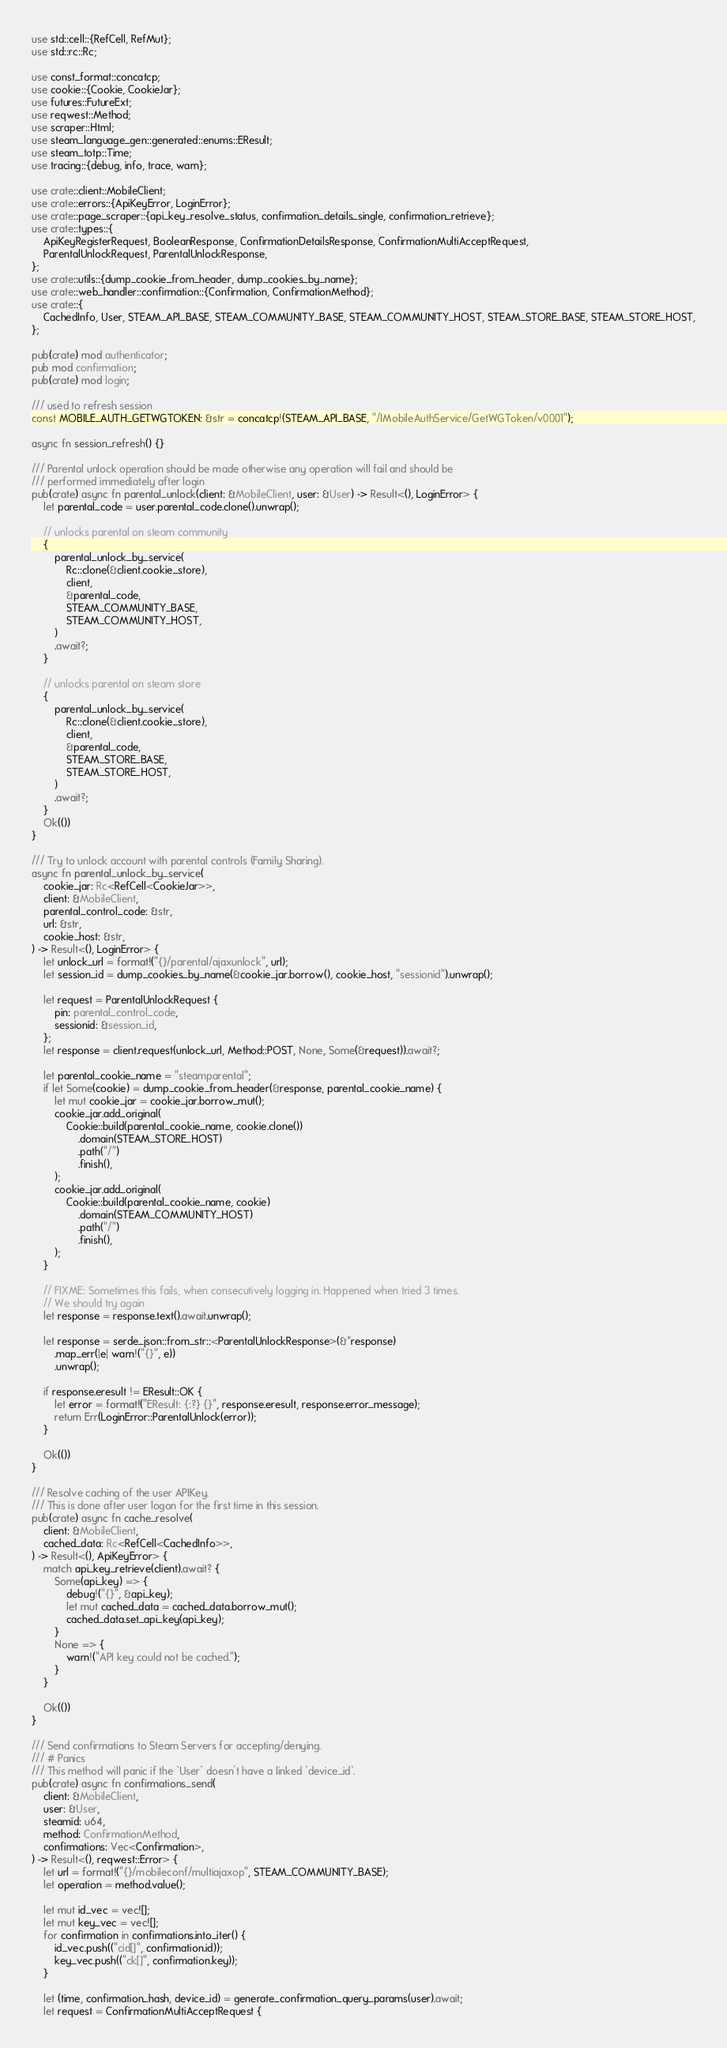Convert code to text. <code><loc_0><loc_0><loc_500><loc_500><_Rust_>use std::cell::{RefCell, RefMut};
use std::rc::Rc;

use const_format::concatcp;
use cookie::{Cookie, CookieJar};
use futures::FutureExt;
use reqwest::Method;
use scraper::Html;
use steam_language_gen::generated::enums::EResult;
use steam_totp::Time;
use tracing::{debug, info, trace, warn};

use crate::client::MobileClient;
use crate::errors::{ApiKeyError, LoginError};
use crate::page_scraper::{api_key_resolve_status, confirmation_details_single, confirmation_retrieve};
use crate::types::{
    ApiKeyRegisterRequest, BooleanResponse, ConfirmationDetailsResponse, ConfirmationMultiAcceptRequest,
    ParentalUnlockRequest, ParentalUnlockResponse,
};
use crate::utils::{dump_cookie_from_header, dump_cookies_by_name};
use crate::web_handler::confirmation::{Confirmation, ConfirmationMethod};
use crate::{
    CachedInfo, User, STEAM_API_BASE, STEAM_COMMUNITY_BASE, STEAM_COMMUNITY_HOST, STEAM_STORE_BASE, STEAM_STORE_HOST,
};

pub(crate) mod authenticator;
pub mod confirmation;
pub(crate) mod login;

/// used to refresh session
const MOBILE_AUTH_GETWGTOKEN: &str = concatcp!(STEAM_API_BASE, "/IMobileAuthService/GetWGToken/v0001");

async fn session_refresh() {}

/// Parental unlock operation should be made otherwise any operation will fail and should be
/// performed immediately after login
pub(crate) async fn parental_unlock(client: &MobileClient, user: &User) -> Result<(), LoginError> {
    let parental_code = user.parental_code.clone().unwrap();

    // unlocks parental on steam community
    {
        parental_unlock_by_service(
            Rc::clone(&client.cookie_store),
            client,
            &parental_code,
            STEAM_COMMUNITY_BASE,
            STEAM_COMMUNITY_HOST,
        )
        .await?;
    }

    // unlocks parental on steam store
    {
        parental_unlock_by_service(
            Rc::clone(&client.cookie_store),
            client,
            &parental_code,
            STEAM_STORE_BASE,
            STEAM_STORE_HOST,
        )
        .await?;
    }
    Ok(())
}

/// Try to unlock account with parental controls (Family Sharing).
async fn parental_unlock_by_service(
    cookie_jar: Rc<RefCell<CookieJar>>,
    client: &MobileClient,
    parental_control_code: &str,
    url: &str,
    cookie_host: &str,
) -> Result<(), LoginError> {
    let unlock_url = format!("{}/parental/ajaxunlock", url);
    let session_id = dump_cookies_by_name(&cookie_jar.borrow(), cookie_host, "sessionid").unwrap();

    let request = ParentalUnlockRequest {
        pin: parental_control_code,
        sessionid: &session_id,
    };
    let response = client.request(unlock_url, Method::POST, None, Some(&request)).await?;

    let parental_cookie_name = "steamparental";
    if let Some(cookie) = dump_cookie_from_header(&response, parental_cookie_name) {
        let mut cookie_jar = cookie_jar.borrow_mut();
        cookie_jar.add_original(
            Cookie::build(parental_cookie_name, cookie.clone())
                .domain(STEAM_STORE_HOST)
                .path("/")
                .finish(),
        );
        cookie_jar.add_original(
            Cookie::build(parental_cookie_name, cookie)
                .domain(STEAM_COMMUNITY_HOST)
                .path("/")
                .finish(),
        );
    }

    // FIXME: Sometimes this fails, when consecutively logging in. Happened when tried 3 times.
    // We should try again
    let response = response.text().await.unwrap();

    let response = serde_json::from_str::<ParentalUnlockResponse>(&*response)
        .map_err(|e| warn!("{}", e))
        .unwrap();

    if response.eresult != EResult::OK {
        let error = format!("EResult: {:?} {}", response.eresult, response.error_message);
        return Err(LoginError::ParentalUnlock(error));
    }

    Ok(())
}

/// Resolve caching of the user APIKey.
/// This is done after user logon for the first time in this session.
pub(crate) async fn cache_resolve(
    client: &MobileClient,
    cached_data: Rc<RefCell<CachedInfo>>,
) -> Result<(), ApiKeyError> {
    match api_key_retrieve(client).await? {
        Some(api_key) => {
            debug!("{}", &api_key);
            let mut cached_data = cached_data.borrow_mut();
            cached_data.set_api_key(api_key);
        }
        None => {
            warn!("API key could not be cached.");
        }
    }

    Ok(())
}

/// Send confirmations to Steam Servers for accepting/denying.
/// # Panics
/// This method will panic if the `User` doesn't have a linked `device_id`.
pub(crate) async fn confirmations_send(
    client: &MobileClient,
    user: &User,
    steamid: u64,
    method: ConfirmationMethod,
    confirmations: Vec<Confirmation>,
) -> Result<(), reqwest::Error> {
    let url = format!("{}/mobileconf/multiajaxop", STEAM_COMMUNITY_BASE);
    let operation = method.value();

    let mut id_vec = vec![];
    let mut key_vec = vec![];
    for confirmation in confirmations.into_iter() {
        id_vec.push(("cid[]", confirmation.id));
        key_vec.push(("ck[]", confirmation.key));
    }

    let (time, confirmation_hash, device_id) = generate_confirmation_query_params(user).await;
    let request = ConfirmationMultiAcceptRequest {</code> 